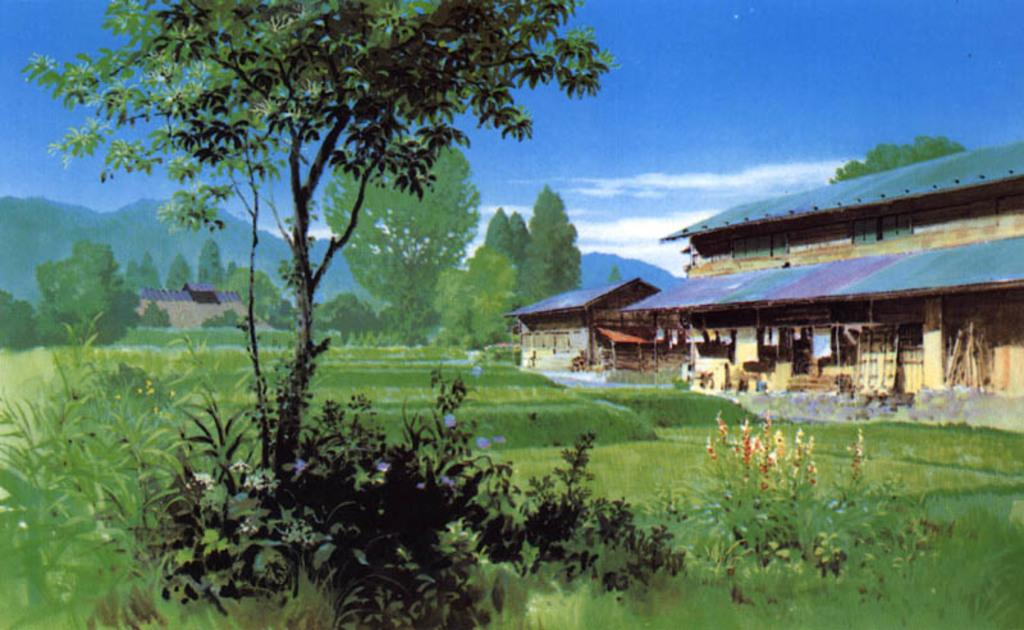What type of artwork is depicted in the image? The image is a painting. What natural elements are present in the painting? There are trees and plants in the painting. Where is the building located in the painting? The building is on the right side of the painting. What can be seen in the background of the painting? There is sky visible in the background of the painting. How many knees are visible in the painting? There are no knees visible in the painting, as it primarily features natural elements and a building. Is there a beggar depicted in the painting? There is no beggar present in the painting; it focuses on trees, plants, a building, and the sky. 